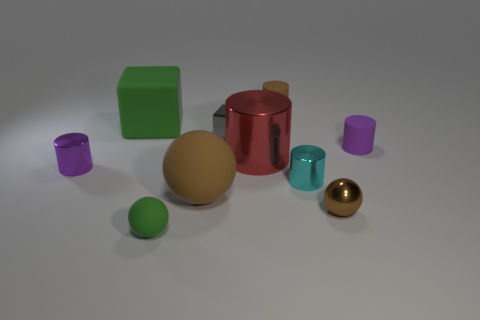Subtract all tiny spheres. How many spheres are left? 1 Subtract all yellow blocks. How many purple cylinders are left? 2 Subtract 1 balls. How many balls are left? 2 Subtract all purple cylinders. How many cylinders are left? 3 Subtract all spheres. How many objects are left? 7 Subtract all yellow spheres. Subtract all cyan cubes. How many spheres are left? 3 Subtract all tiny blue metallic blocks. Subtract all small purple objects. How many objects are left? 8 Add 9 big red metal objects. How many big red metal objects are left? 10 Add 6 tiny rubber things. How many tiny rubber things exist? 9 Subtract 0 purple balls. How many objects are left? 10 